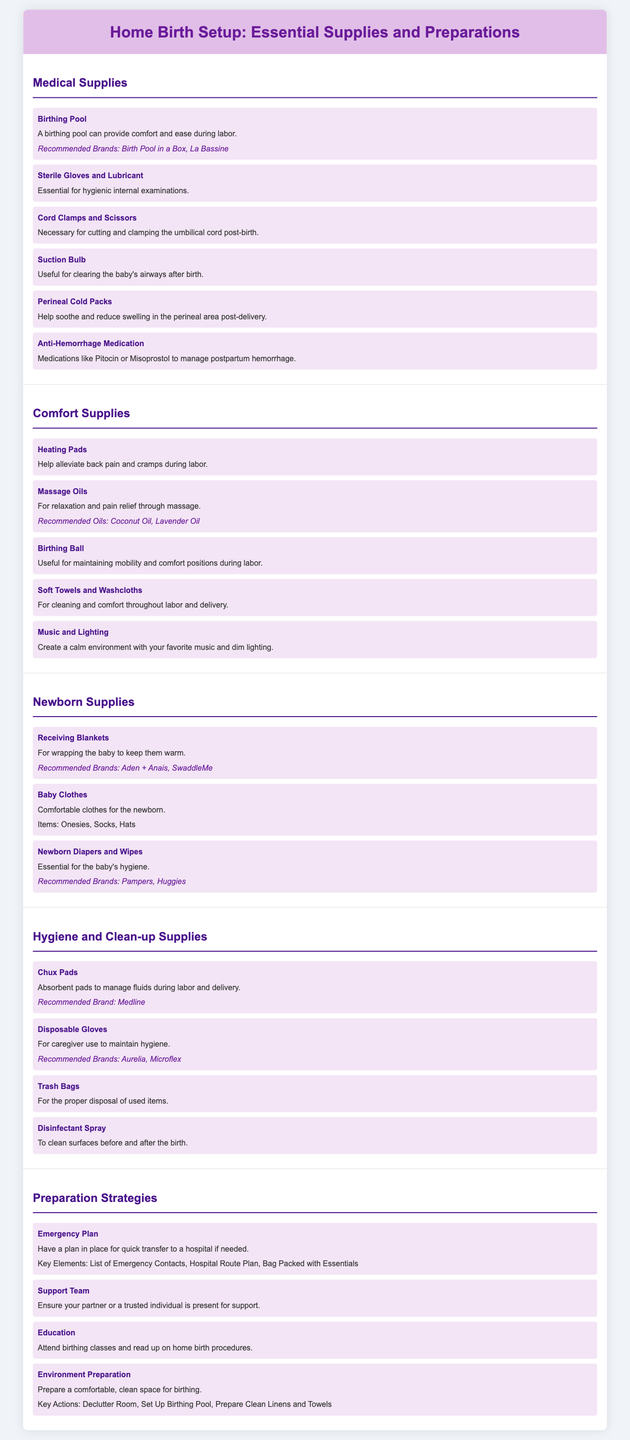What is the recommended brand for a birthing pool? The document lists "Birth Pool in a Box" and "La Bassine" as recommended brands for a birthing pool.
Answer: Birth Pool in a Box, La Bassine What item is essential for hygienic internal examinations? The document specifies "Sterile Gloves and Lubricant" as essential for hygienic internal examinations.
Answer: Sterile Gloves and Lubricant What type of medication is mentioned for managing postpartum hemorrhage? The document refers to "Anti-Hemorrhage Medication" such as Pitocin or Misoprostol for managing postpartum hemorrhage.
Answer: Anti-Hemorrhage Medication Which supplies are suggested to create a calm environment? "Music and Lighting" are mentioned as supplies to create a calm environment during labor.
Answer: Music and Lighting What is one of the recommended brands for newborn diapers? The document states "Pampers" and "Huggies" as recommended brands for newborn diapers.
Answer: Pampers, Huggies What should be included in an emergency plan? The document highlights "List of Emergency Contacts, Hospital Route Plan, Bag Packed with Essentials" as key elements to include in an emergency plan.
Answer: List of Emergency Contacts, Hospital Route Plan, Bag Packed with Essentials How many sections are there in the document? The document contains five main sections discussing different aspects of home birth setup.
Answer: Five What are Chux Pads used for? The document describes "Chux Pads" as absorbent pads to manage fluids during labor and delivery.
Answer: Manage fluids during labor and delivery What is an example of a comfort supply? The document lists "Heating Pads" as an example of a comfort supply useful during labor.
Answer: Heating Pads 